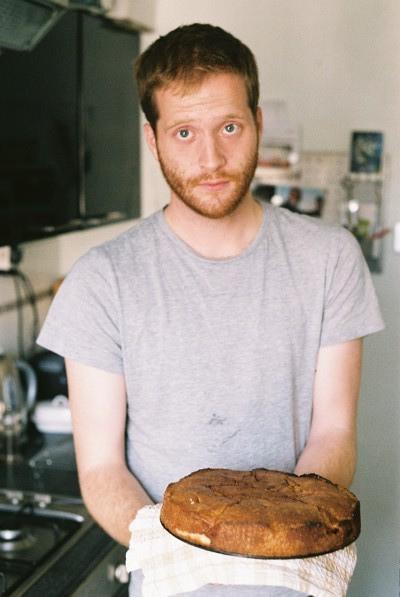What color are the cupboards?
Short answer required. Black. Is this man proud of the cake he made?
Give a very brief answer. No. What is the man holding the cake with?
Quick response, please. Towel. What color is the man's shirt?
Concise answer only. Gray. 